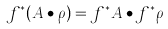<formula> <loc_0><loc_0><loc_500><loc_500>f ^ { * } ( A \bullet \rho ) = f ^ { * } A \bullet f ^ { * } \rho</formula> 